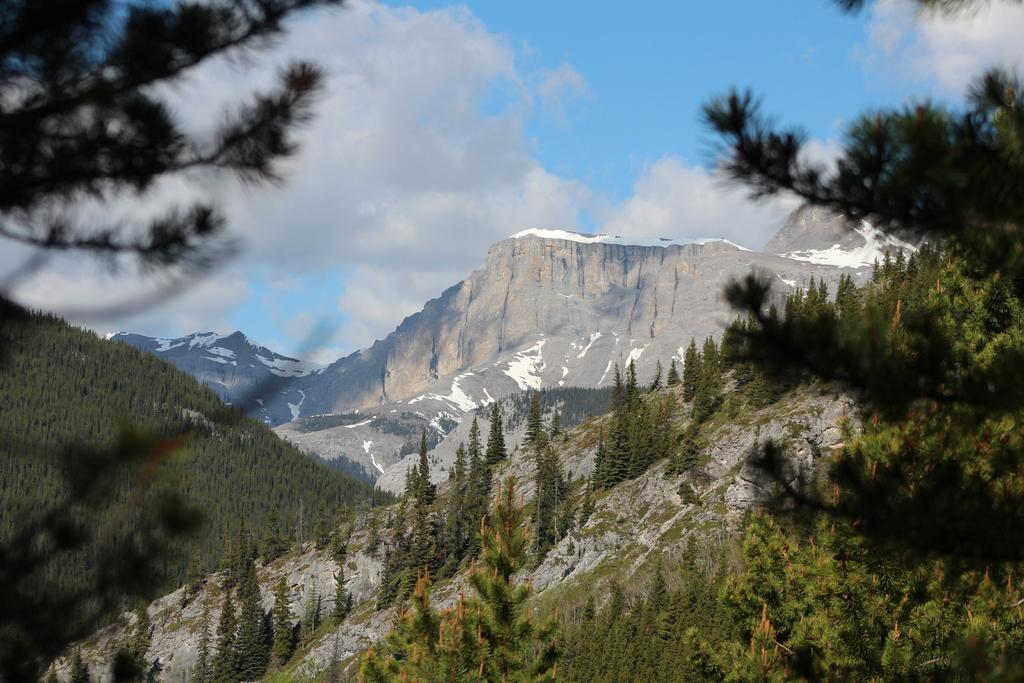What is visible at the top of the image? The sky is visible in the image. What can be seen in the sky? Clouds are present in the sky. What type of landforms are in the image? There are mountains and hills in the image. What type of vegetation is present in the image? Trees are present in the image. What type of head can be seen in the image? There is no head present in the image. 